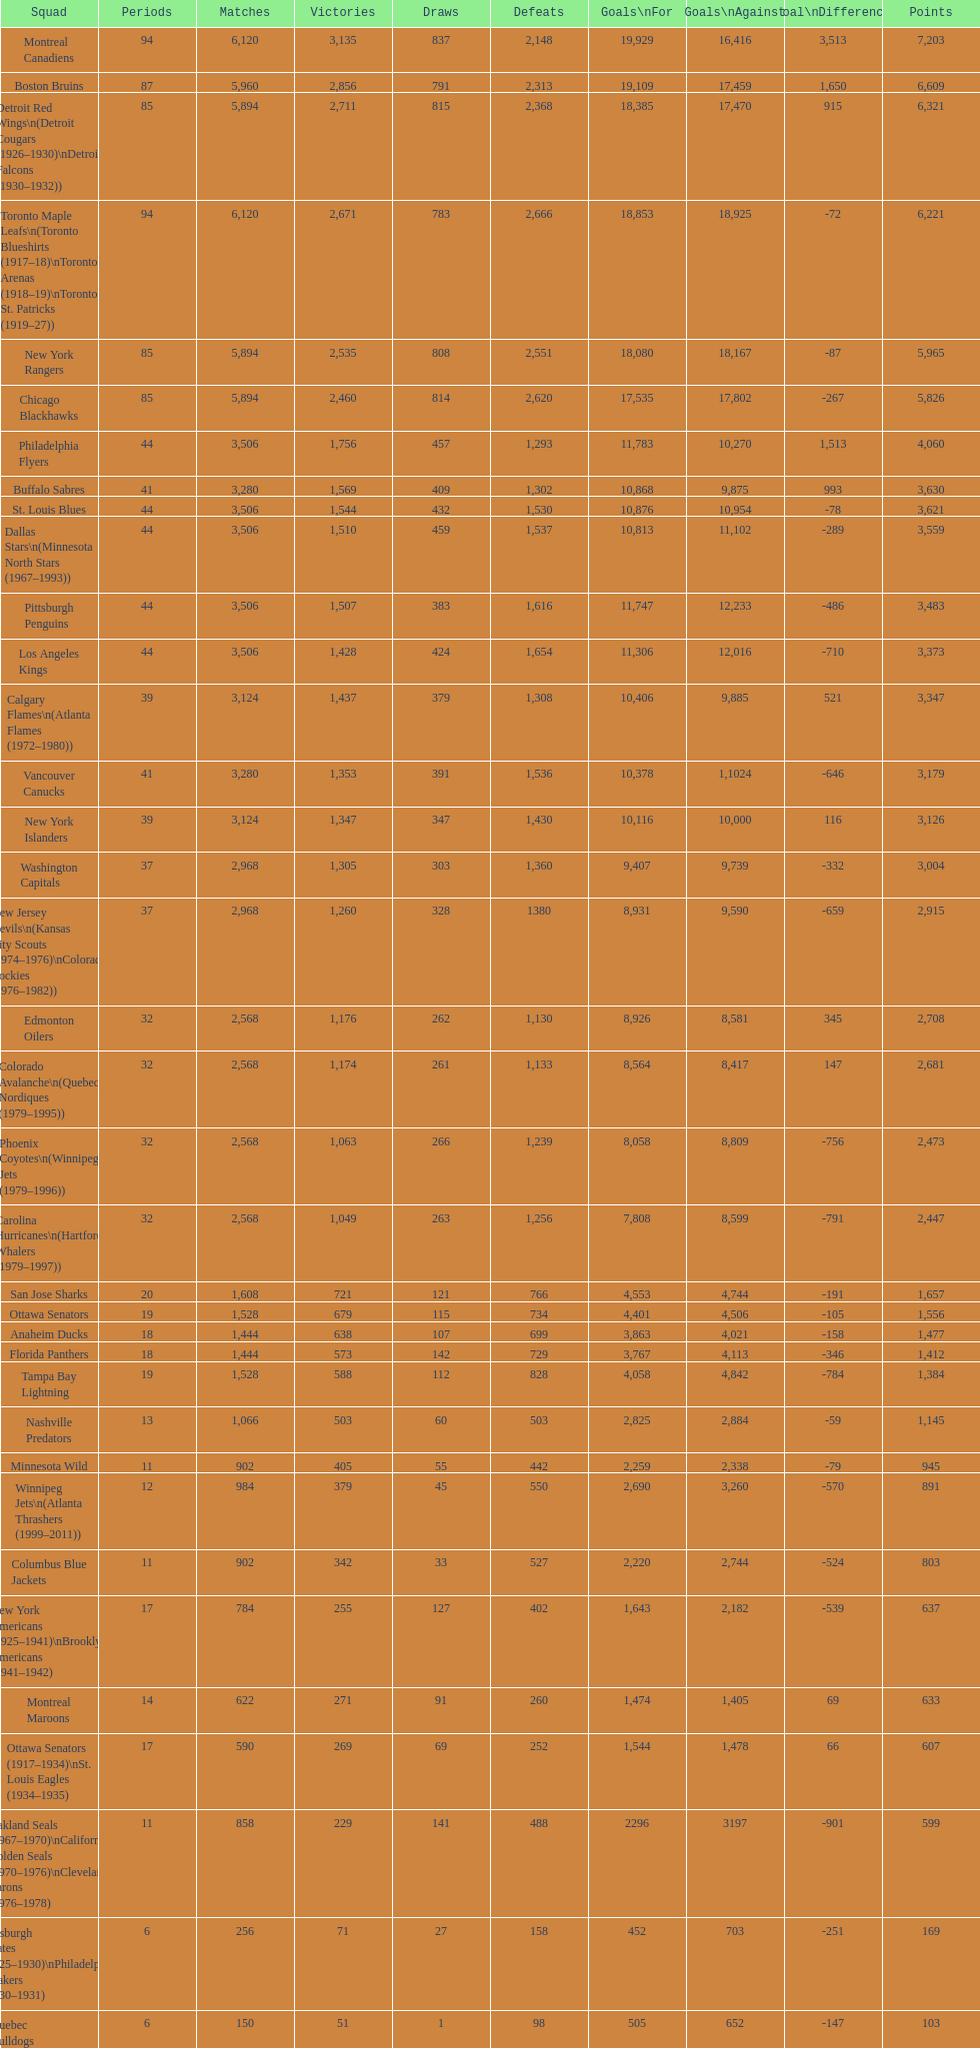Who is at the top of the list? Montreal Canadiens. 